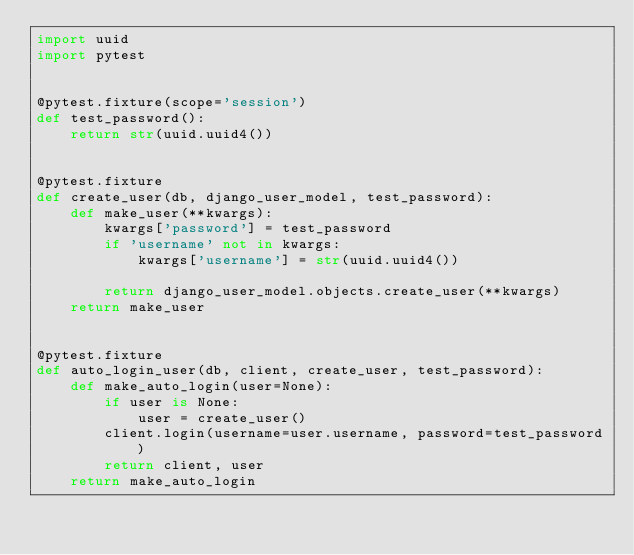Convert code to text. <code><loc_0><loc_0><loc_500><loc_500><_Python_>import uuid
import pytest


@pytest.fixture(scope='session')
def test_password():
    return str(uuid.uuid4())


@pytest.fixture
def create_user(db, django_user_model, test_password):
    def make_user(**kwargs):
        kwargs['password'] = test_password
        if 'username' not in kwargs:
            kwargs['username'] = str(uuid.uuid4())

        return django_user_model.objects.create_user(**kwargs)
    return make_user


@pytest.fixture
def auto_login_user(db, client, create_user, test_password):
    def make_auto_login(user=None):
        if user is None:
            user = create_user()
        client.login(username=user.username, password=test_password)
        return client, user
    return make_auto_login
</code> 